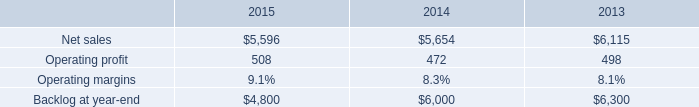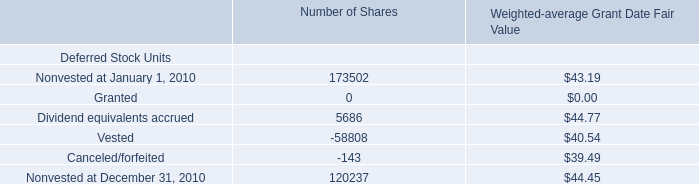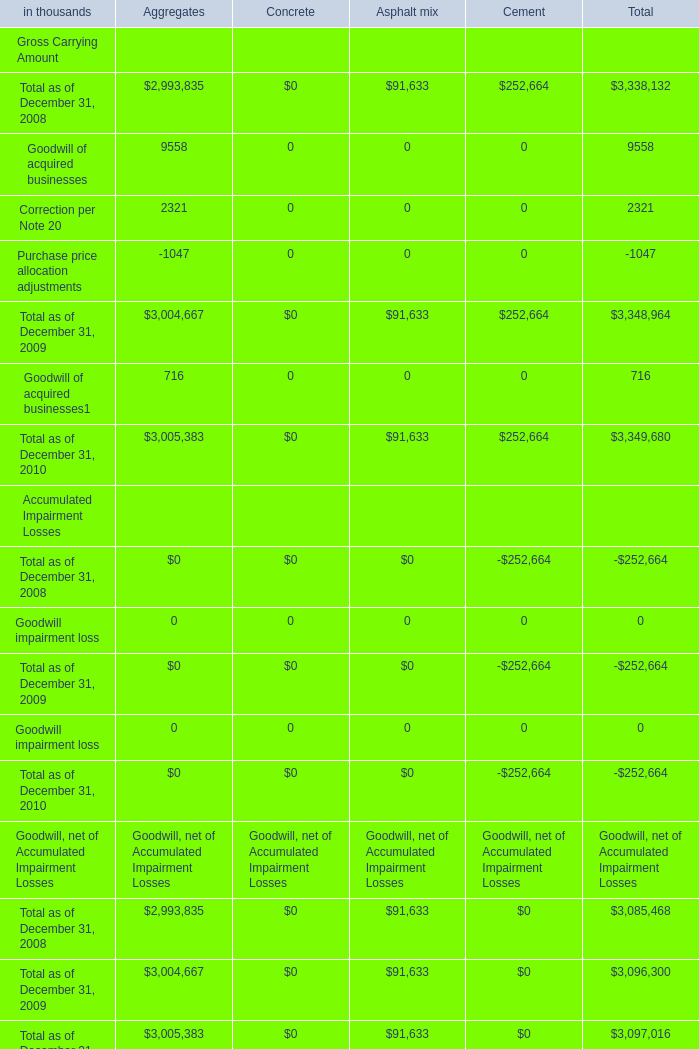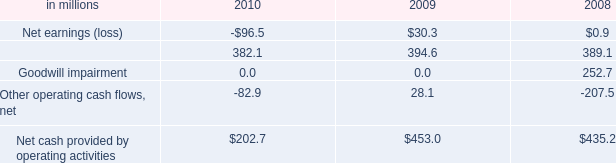What is the sum of Goodwill, net of Accumulated Impairment Losses for Total as of December 31, 2009 for Aggregates and Dividend equivalents accrued for Number of Shares for 2010? 
Computations: (5686 + 3004667)
Answer: 3010353.0. 